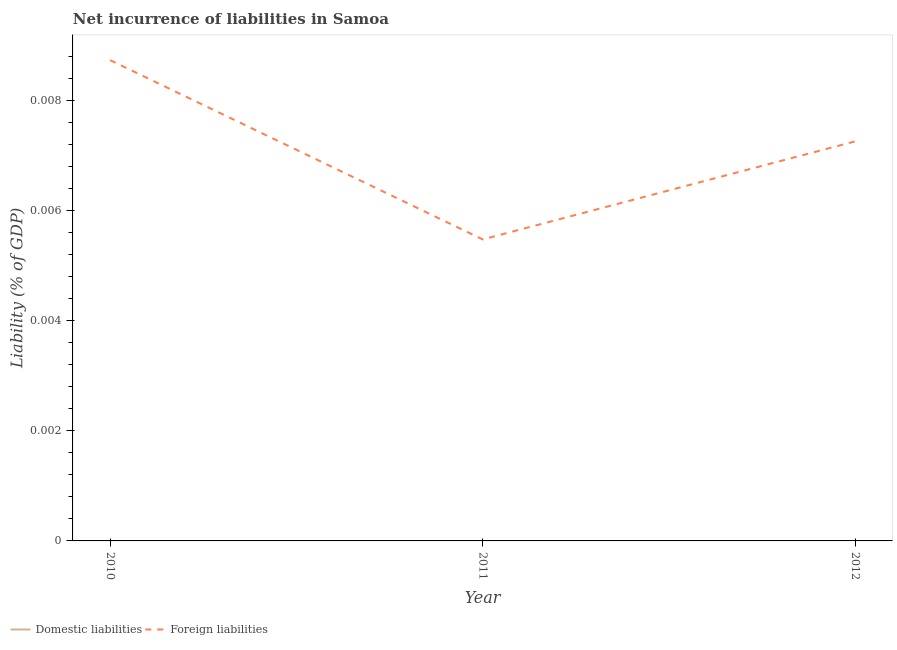How many different coloured lines are there?
Provide a short and direct response. 1. Is the number of lines equal to the number of legend labels?
Keep it short and to the point. No. Across all years, what is the maximum incurrence of foreign liabilities?
Provide a short and direct response. 0.01. What is the difference between the incurrence of foreign liabilities in 2011 and that in 2012?
Your response must be concise. -0. What is the difference between the incurrence of foreign liabilities in 2012 and the incurrence of domestic liabilities in 2010?
Your answer should be very brief. 0.01. What is the average incurrence of foreign liabilities per year?
Give a very brief answer. 0.01. What is the ratio of the incurrence of foreign liabilities in 2011 to that in 2012?
Ensure brevity in your answer.  0.75. Is the incurrence of foreign liabilities in 2010 less than that in 2012?
Keep it short and to the point. No. What is the difference between the highest and the second highest incurrence of foreign liabilities?
Offer a very short reply. 0. What is the difference between the highest and the lowest incurrence of foreign liabilities?
Offer a very short reply. 0. Is the incurrence of domestic liabilities strictly greater than the incurrence of foreign liabilities over the years?
Your answer should be compact. No. How many years are there in the graph?
Give a very brief answer. 3. What is the difference between two consecutive major ticks on the Y-axis?
Offer a very short reply. 0. Where does the legend appear in the graph?
Ensure brevity in your answer.  Bottom left. How many legend labels are there?
Provide a short and direct response. 2. What is the title of the graph?
Keep it short and to the point. Net incurrence of liabilities in Samoa. What is the label or title of the X-axis?
Offer a very short reply. Year. What is the label or title of the Y-axis?
Give a very brief answer. Liability (% of GDP). What is the Liability (% of GDP) in Foreign liabilities in 2010?
Offer a very short reply. 0.01. What is the Liability (% of GDP) of Domestic liabilities in 2011?
Ensure brevity in your answer.  0. What is the Liability (% of GDP) in Foreign liabilities in 2011?
Offer a terse response. 0.01. What is the Liability (% of GDP) of Foreign liabilities in 2012?
Your answer should be compact. 0.01. Across all years, what is the maximum Liability (% of GDP) in Foreign liabilities?
Ensure brevity in your answer.  0.01. Across all years, what is the minimum Liability (% of GDP) in Foreign liabilities?
Your answer should be very brief. 0.01. What is the total Liability (% of GDP) in Domestic liabilities in the graph?
Give a very brief answer. 0. What is the total Liability (% of GDP) of Foreign liabilities in the graph?
Give a very brief answer. 0.02. What is the difference between the Liability (% of GDP) of Foreign liabilities in 2010 and that in 2011?
Provide a succinct answer. 0. What is the difference between the Liability (% of GDP) of Foreign liabilities in 2010 and that in 2012?
Offer a terse response. 0. What is the difference between the Liability (% of GDP) in Foreign liabilities in 2011 and that in 2012?
Your response must be concise. -0. What is the average Liability (% of GDP) in Foreign liabilities per year?
Offer a terse response. 0.01. What is the ratio of the Liability (% of GDP) of Foreign liabilities in 2010 to that in 2011?
Your answer should be very brief. 1.59. What is the ratio of the Liability (% of GDP) of Foreign liabilities in 2010 to that in 2012?
Give a very brief answer. 1.2. What is the ratio of the Liability (% of GDP) in Foreign liabilities in 2011 to that in 2012?
Provide a short and direct response. 0.75. What is the difference between the highest and the second highest Liability (% of GDP) in Foreign liabilities?
Offer a terse response. 0. What is the difference between the highest and the lowest Liability (% of GDP) of Foreign liabilities?
Keep it short and to the point. 0. 